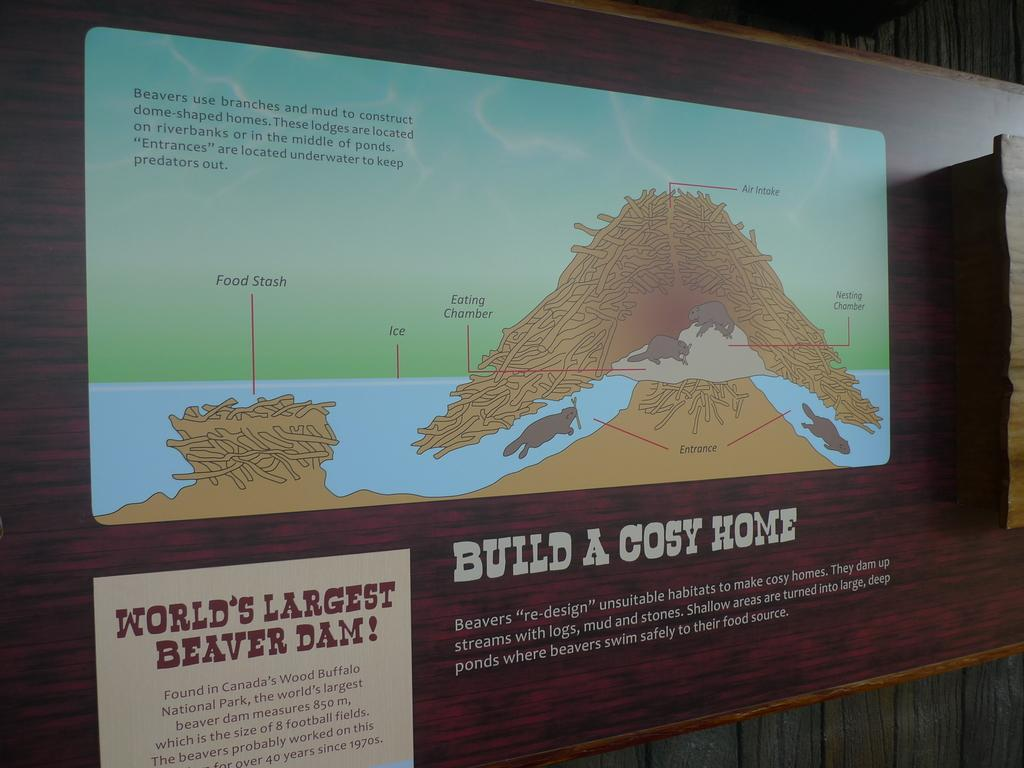Provide a one-sentence caption for the provided image. Worlds largest beaver damn sign from what is likely a park or zoo. 